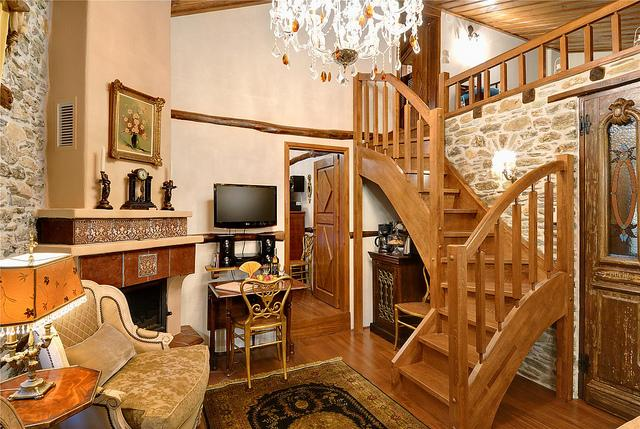What form of heating is used here?

Choices:
A) steam
B) coal
C) gas
D) wood wood 